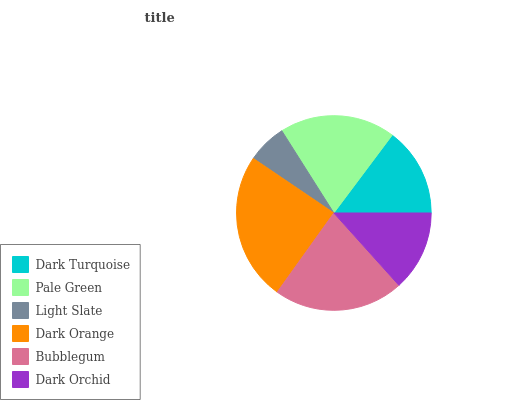Is Light Slate the minimum?
Answer yes or no. Yes. Is Dark Orange the maximum?
Answer yes or no. Yes. Is Pale Green the minimum?
Answer yes or no. No. Is Pale Green the maximum?
Answer yes or no. No. Is Pale Green greater than Dark Turquoise?
Answer yes or no. Yes. Is Dark Turquoise less than Pale Green?
Answer yes or no. Yes. Is Dark Turquoise greater than Pale Green?
Answer yes or no. No. Is Pale Green less than Dark Turquoise?
Answer yes or no. No. Is Pale Green the high median?
Answer yes or no. Yes. Is Dark Turquoise the low median?
Answer yes or no. Yes. Is Dark Orange the high median?
Answer yes or no. No. Is Dark Orchid the low median?
Answer yes or no. No. 